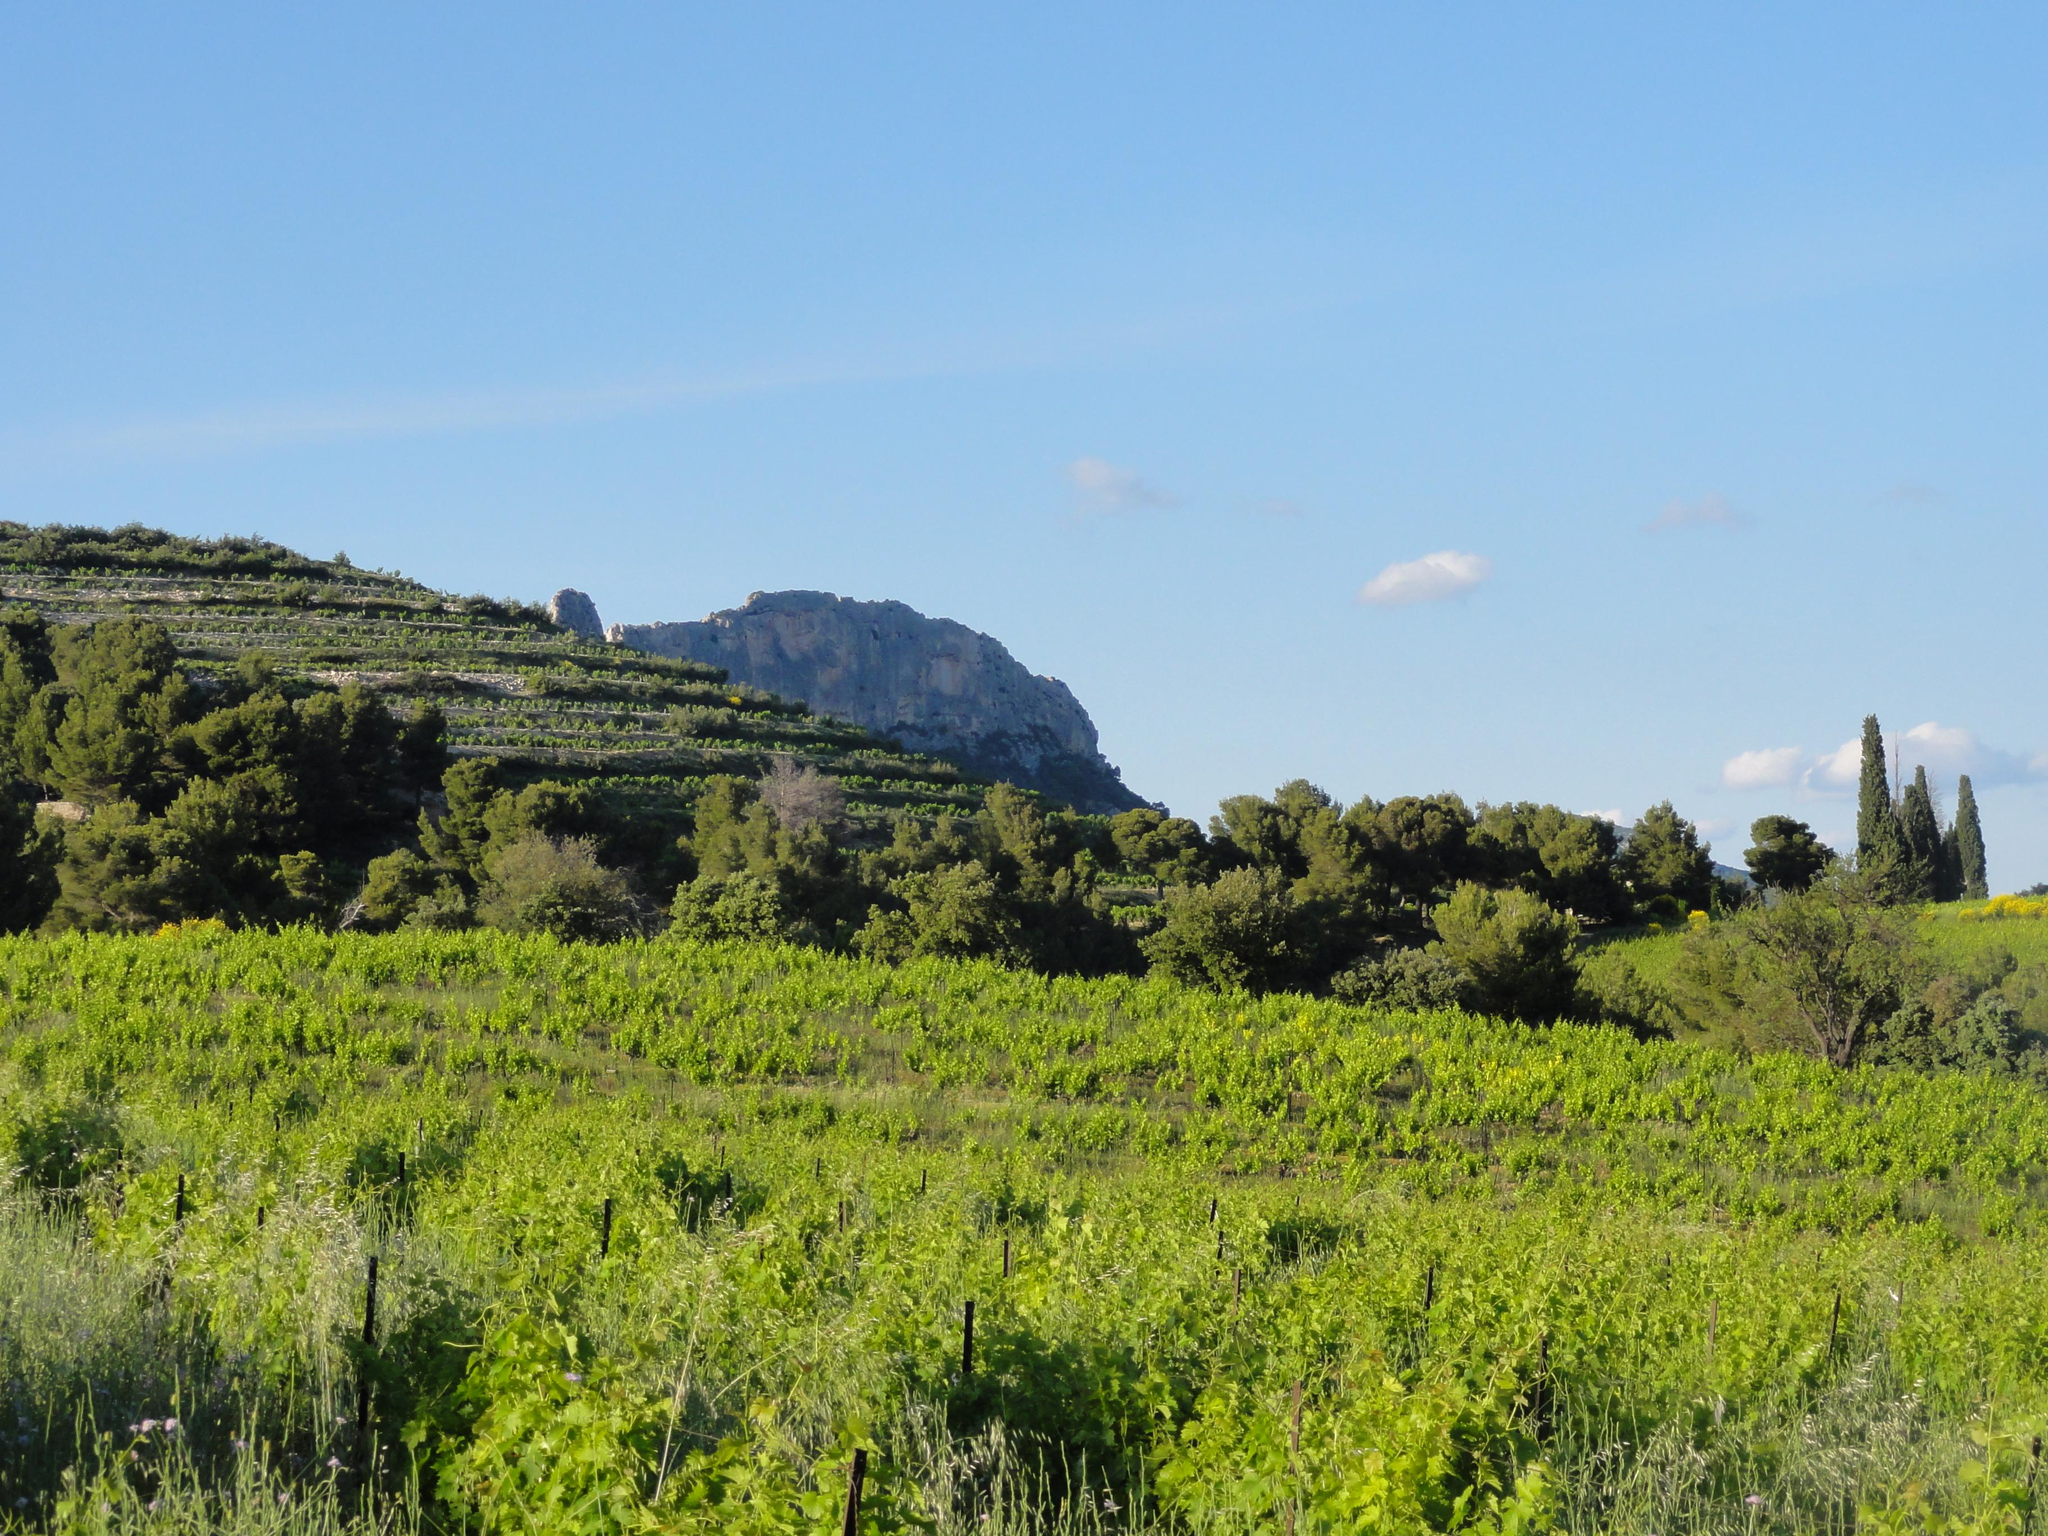What type of vegetation is present on the ground in the image? There are many plants on the ground in the image. What can be seen in the background of the image? There are hills with trees in the background of the image. What is visible at the top of the image? The sky is visible at the top of the image. What type of ground cover is present at the bottom of the image? There is grass at the bottom of the image. Can you see any quivers in the image? There is no mention of quivers in the provided facts, and therefore, we cannot determine if any are present in the image. What type of trousers are the trees wearing in the image? Trees do not wear trousers, as they are not human or sentient beings. 